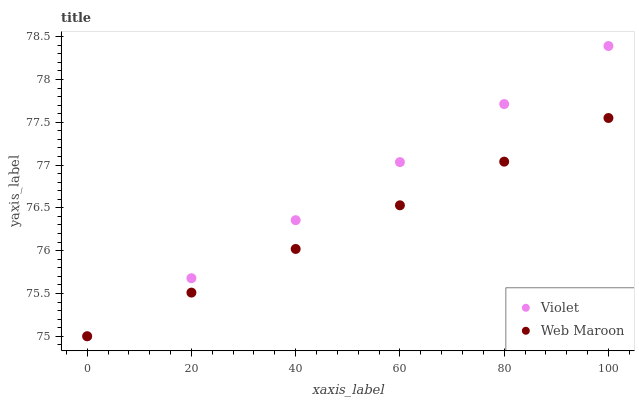Does Web Maroon have the minimum area under the curve?
Answer yes or no. Yes. Does Violet have the maximum area under the curve?
Answer yes or no. Yes. Does Violet have the minimum area under the curve?
Answer yes or no. No. Is Violet the smoothest?
Answer yes or no. Yes. Is Web Maroon the roughest?
Answer yes or no. Yes. Is Violet the roughest?
Answer yes or no. No. Does Web Maroon have the lowest value?
Answer yes or no. Yes. Does Violet have the highest value?
Answer yes or no. Yes. Does Web Maroon intersect Violet?
Answer yes or no. Yes. Is Web Maroon less than Violet?
Answer yes or no. No. Is Web Maroon greater than Violet?
Answer yes or no. No. 